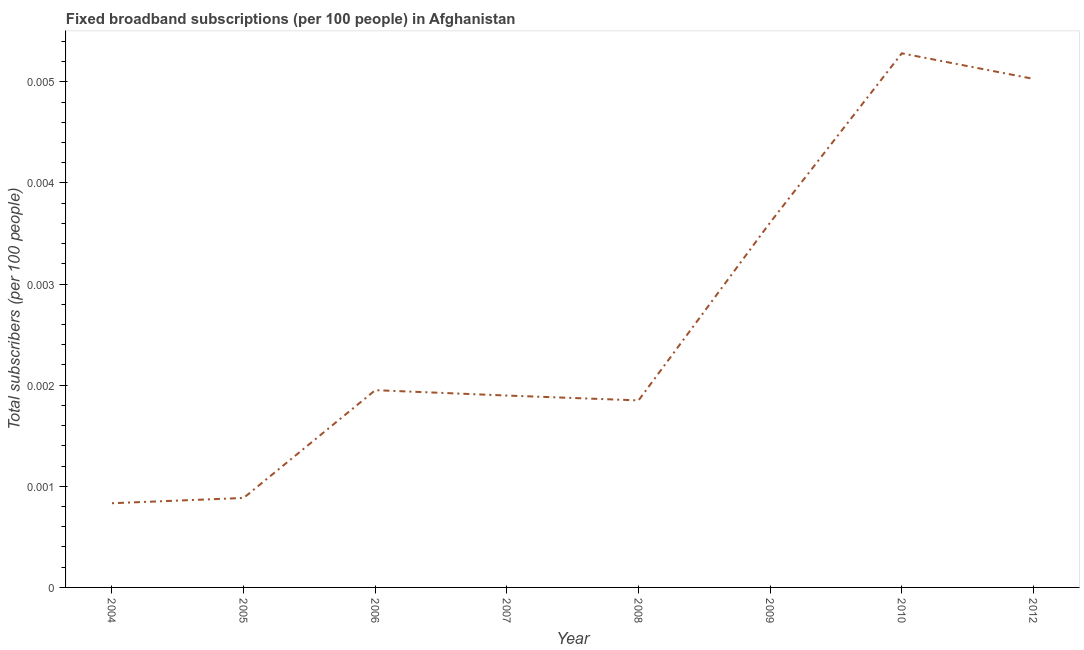What is the total number of fixed broadband subscriptions in 2008?
Provide a succinct answer. 0. Across all years, what is the maximum total number of fixed broadband subscriptions?
Provide a succinct answer. 0.01. Across all years, what is the minimum total number of fixed broadband subscriptions?
Provide a succinct answer. 0. In which year was the total number of fixed broadband subscriptions maximum?
Your answer should be very brief. 2010. What is the sum of the total number of fixed broadband subscriptions?
Offer a terse response. 0.02. What is the difference between the total number of fixed broadband subscriptions in 2004 and 2012?
Provide a succinct answer. -0. What is the average total number of fixed broadband subscriptions per year?
Provide a short and direct response. 0. What is the median total number of fixed broadband subscriptions?
Provide a succinct answer. 0. In how many years, is the total number of fixed broadband subscriptions greater than 0.0042 ?
Your response must be concise. 2. Do a majority of the years between 2012 and 2005 (inclusive) have total number of fixed broadband subscriptions greater than 0.0038 ?
Offer a terse response. Yes. What is the ratio of the total number of fixed broadband subscriptions in 2007 to that in 2009?
Your response must be concise. 0.53. What is the difference between the highest and the second highest total number of fixed broadband subscriptions?
Give a very brief answer. 0. Is the sum of the total number of fixed broadband subscriptions in 2005 and 2010 greater than the maximum total number of fixed broadband subscriptions across all years?
Your answer should be very brief. Yes. What is the difference between the highest and the lowest total number of fixed broadband subscriptions?
Provide a succinct answer. 0. In how many years, is the total number of fixed broadband subscriptions greater than the average total number of fixed broadband subscriptions taken over all years?
Your answer should be very brief. 3. How many years are there in the graph?
Provide a short and direct response. 8. Are the values on the major ticks of Y-axis written in scientific E-notation?
Give a very brief answer. No. What is the title of the graph?
Provide a succinct answer. Fixed broadband subscriptions (per 100 people) in Afghanistan. What is the label or title of the X-axis?
Your response must be concise. Year. What is the label or title of the Y-axis?
Provide a succinct answer. Total subscribers (per 100 people). What is the Total subscribers (per 100 people) of 2004?
Your answer should be compact. 0. What is the Total subscribers (per 100 people) of 2005?
Provide a short and direct response. 0. What is the Total subscribers (per 100 people) of 2006?
Keep it short and to the point. 0. What is the Total subscribers (per 100 people) of 2007?
Make the answer very short. 0. What is the Total subscribers (per 100 people) of 2008?
Your response must be concise. 0. What is the Total subscribers (per 100 people) of 2009?
Keep it short and to the point. 0. What is the Total subscribers (per 100 people) in 2010?
Your answer should be compact. 0.01. What is the Total subscribers (per 100 people) in 2012?
Give a very brief answer. 0.01. What is the difference between the Total subscribers (per 100 people) in 2004 and 2005?
Your answer should be compact. -5e-5. What is the difference between the Total subscribers (per 100 people) in 2004 and 2006?
Keep it short and to the point. -0. What is the difference between the Total subscribers (per 100 people) in 2004 and 2007?
Provide a short and direct response. -0. What is the difference between the Total subscribers (per 100 people) in 2004 and 2008?
Your answer should be compact. -0. What is the difference between the Total subscribers (per 100 people) in 2004 and 2009?
Offer a very short reply. -0. What is the difference between the Total subscribers (per 100 people) in 2004 and 2010?
Offer a terse response. -0. What is the difference between the Total subscribers (per 100 people) in 2004 and 2012?
Your answer should be very brief. -0. What is the difference between the Total subscribers (per 100 people) in 2005 and 2006?
Your answer should be very brief. -0. What is the difference between the Total subscribers (per 100 people) in 2005 and 2007?
Your answer should be compact. -0. What is the difference between the Total subscribers (per 100 people) in 2005 and 2008?
Offer a terse response. -0. What is the difference between the Total subscribers (per 100 people) in 2005 and 2009?
Ensure brevity in your answer.  -0. What is the difference between the Total subscribers (per 100 people) in 2005 and 2010?
Your response must be concise. -0. What is the difference between the Total subscribers (per 100 people) in 2005 and 2012?
Provide a succinct answer. -0. What is the difference between the Total subscribers (per 100 people) in 2006 and 2007?
Offer a very short reply. 5e-5. What is the difference between the Total subscribers (per 100 people) in 2006 and 2009?
Offer a very short reply. -0. What is the difference between the Total subscribers (per 100 people) in 2006 and 2010?
Provide a short and direct response. -0. What is the difference between the Total subscribers (per 100 people) in 2006 and 2012?
Provide a short and direct response. -0. What is the difference between the Total subscribers (per 100 people) in 2007 and 2008?
Keep it short and to the point. 5e-5. What is the difference between the Total subscribers (per 100 people) in 2007 and 2009?
Give a very brief answer. -0. What is the difference between the Total subscribers (per 100 people) in 2007 and 2010?
Your response must be concise. -0. What is the difference between the Total subscribers (per 100 people) in 2007 and 2012?
Give a very brief answer. -0. What is the difference between the Total subscribers (per 100 people) in 2008 and 2009?
Your answer should be very brief. -0. What is the difference between the Total subscribers (per 100 people) in 2008 and 2010?
Keep it short and to the point. -0. What is the difference between the Total subscribers (per 100 people) in 2008 and 2012?
Make the answer very short. -0. What is the difference between the Total subscribers (per 100 people) in 2009 and 2010?
Keep it short and to the point. -0. What is the difference between the Total subscribers (per 100 people) in 2009 and 2012?
Offer a terse response. -0. What is the difference between the Total subscribers (per 100 people) in 2010 and 2012?
Make the answer very short. 0. What is the ratio of the Total subscribers (per 100 people) in 2004 to that in 2005?
Give a very brief answer. 0.94. What is the ratio of the Total subscribers (per 100 people) in 2004 to that in 2006?
Make the answer very short. 0.43. What is the ratio of the Total subscribers (per 100 people) in 2004 to that in 2007?
Your answer should be compact. 0.44. What is the ratio of the Total subscribers (per 100 people) in 2004 to that in 2008?
Provide a succinct answer. 0.45. What is the ratio of the Total subscribers (per 100 people) in 2004 to that in 2009?
Your answer should be compact. 0.23. What is the ratio of the Total subscribers (per 100 people) in 2004 to that in 2010?
Keep it short and to the point. 0.16. What is the ratio of the Total subscribers (per 100 people) in 2004 to that in 2012?
Keep it short and to the point. 0.17. What is the ratio of the Total subscribers (per 100 people) in 2005 to that in 2006?
Your answer should be compact. 0.45. What is the ratio of the Total subscribers (per 100 people) in 2005 to that in 2007?
Your response must be concise. 0.47. What is the ratio of the Total subscribers (per 100 people) in 2005 to that in 2008?
Ensure brevity in your answer.  0.48. What is the ratio of the Total subscribers (per 100 people) in 2005 to that in 2009?
Ensure brevity in your answer.  0.24. What is the ratio of the Total subscribers (per 100 people) in 2005 to that in 2010?
Make the answer very short. 0.17. What is the ratio of the Total subscribers (per 100 people) in 2005 to that in 2012?
Your response must be concise. 0.18. What is the ratio of the Total subscribers (per 100 people) in 2006 to that in 2007?
Your answer should be compact. 1.03. What is the ratio of the Total subscribers (per 100 people) in 2006 to that in 2008?
Offer a terse response. 1.05. What is the ratio of the Total subscribers (per 100 people) in 2006 to that in 2009?
Make the answer very short. 0.54. What is the ratio of the Total subscribers (per 100 people) in 2006 to that in 2010?
Give a very brief answer. 0.37. What is the ratio of the Total subscribers (per 100 people) in 2006 to that in 2012?
Give a very brief answer. 0.39. What is the ratio of the Total subscribers (per 100 people) in 2007 to that in 2008?
Offer a terse response. 1.03. What is the ratio of the Total subscribers (per 100 people) in 2007 to that in 2009?
Your answer should be compact. 0.53. What is the ratio of the Total subscribers (per 100 people) in 2007 to that in 2010?
Make the answer very short. 0.36. What is the ratio of the Total subscribers (per 100 people) in 2007 to that in 2012?
Your answer should be compact. 0.38. What is the ratio of the Total subscribers (per 100 people) in 2008 to that in 2009?
Your response must be concise. 0.51. What is the ratio of the Total subscribers (per 100 people) in 2008 to that in 2010?
Ensure brevity in your answer.  0.35. What is the ratio of the Total subscribers (per 100 people) in 2008 to that in 2012?
Give a very brief answer. 0.37. What is the ratio of the Total subscribers (per 100 people) in 2009 to that in 2010?
Keep it short and to the point. 0.68. What is the ratio of the Total subscribers (per 100 people) in 2009 to that in 2012?
Provide a short and direct response. 0.72. 